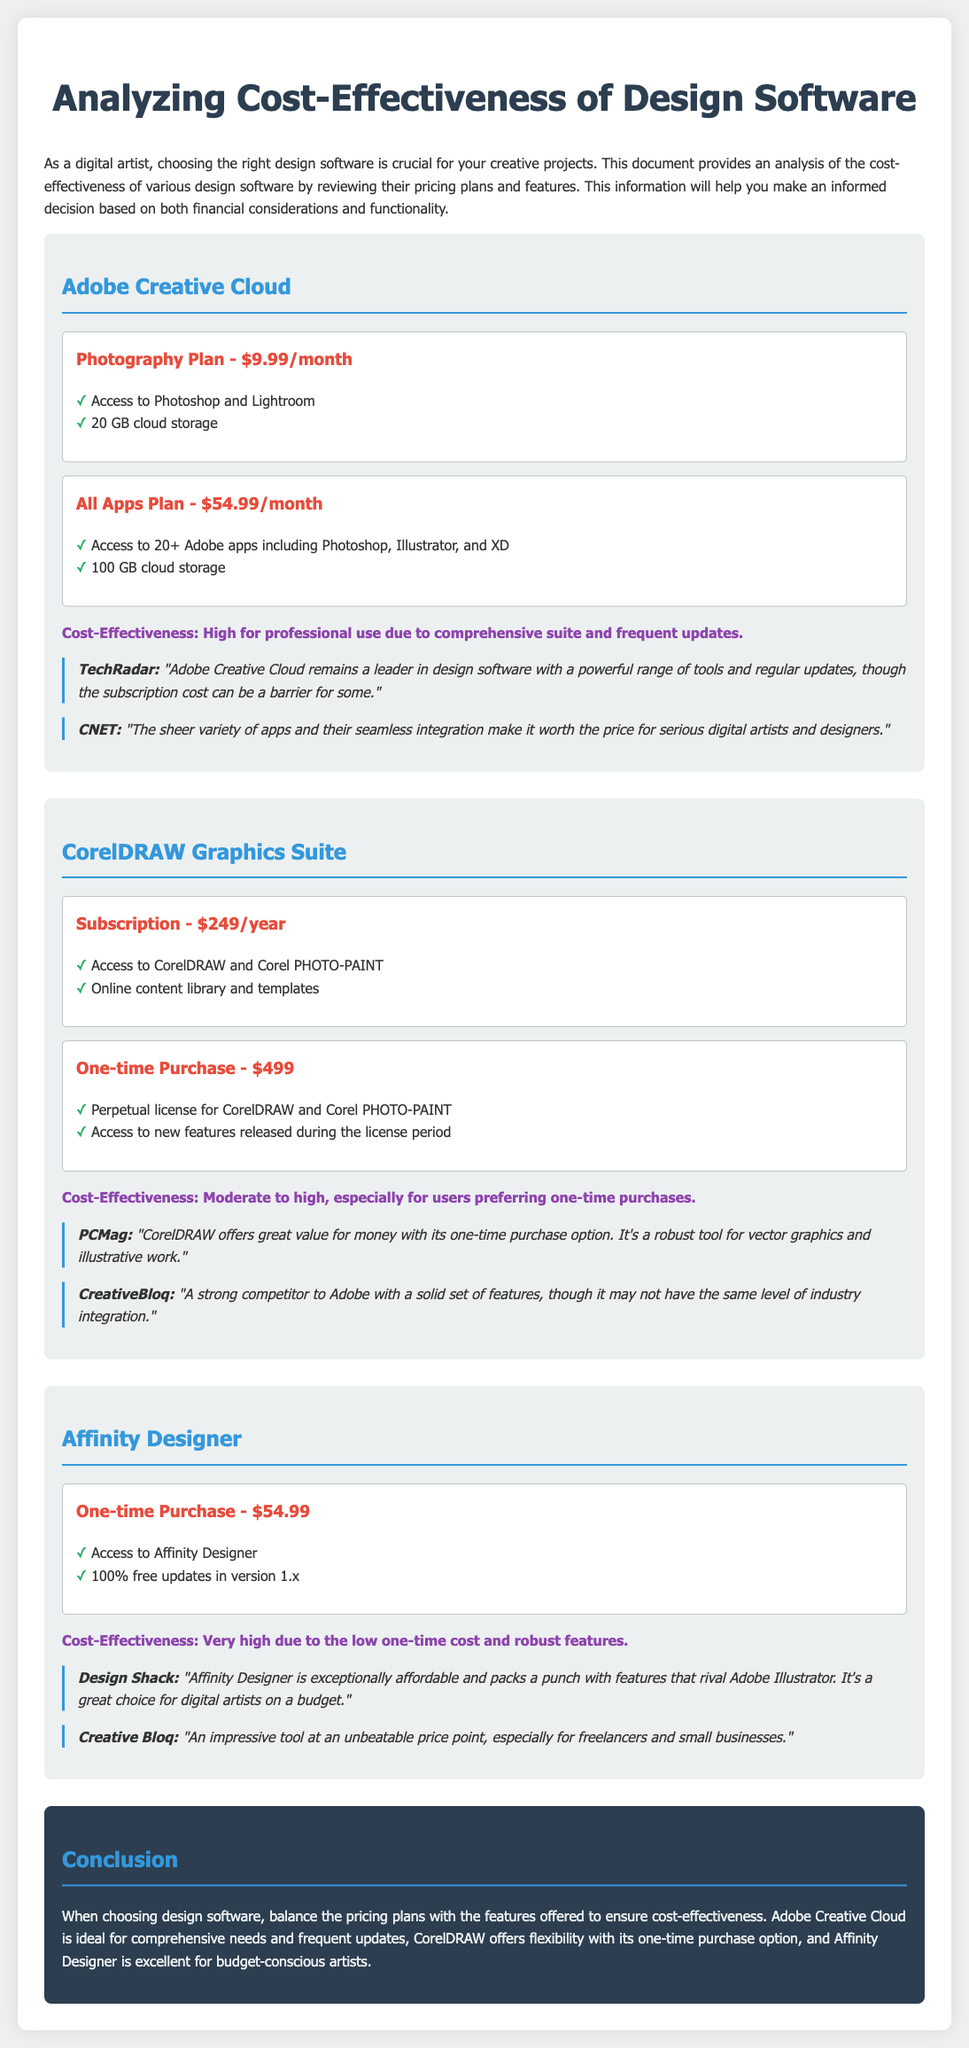What is the cost of the Adobe Photography Plan? The Adobe Photography Plan costs $9.99 per month.
Answer: $9.99/month How much storage is included in the All Apps Plan of Adobe Creative Cloud? The All Apps Plan includes 100 GB of cloud storage.
Answer: 100 GB What is the one-time purchase price of CorelDRAW Graphics Suite? The one-time purchase price of CorelDRAW Graphics Suite is $499.
Answer: $499 Which software offers a very high cost-effectiveness due to its low price? Affinity Designer is noted for its very high cost-effectiveness due to the low one-time cost.
Answer: Affinity Designer Which review source mentions that CorelDRAW is a strong competitor to Adobe? CreativeBloq mentions that CorelDRAW is a strong competitor to Adobe.
Answer: CreativeBloq How many Adobe apps are included in the All Apps Plan? The All Apps Plan includes access to 20+ Adobe apps.
Answer: 20+ What type of license is offered with the one-time purchase of CorelDRAW? The one-time purchase provides a perpetual license.
Answer: Perpetual license What is the monthly cost of the CorelDRAW subscription plan? The CorelDRAW subscription plan costs $249 per year, which translates to about $20.75 per month.
Answer: $249/year What is the review rating given to Affinity Designer by Design Shack? Design Shack states that Affinity Designer is "exceptionally affordable and packs a punch with features".
Answer: Exceptionally affordable 